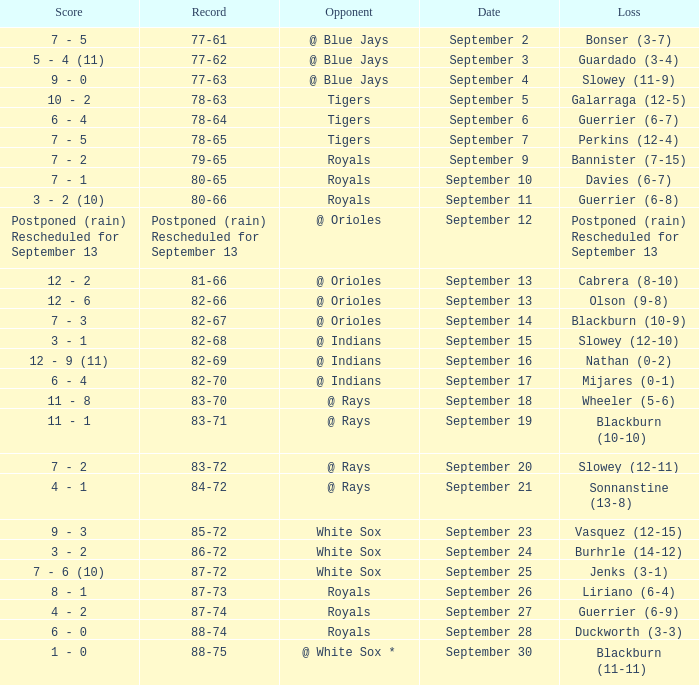What opponnent has a record of 82-68? @ Indians. 